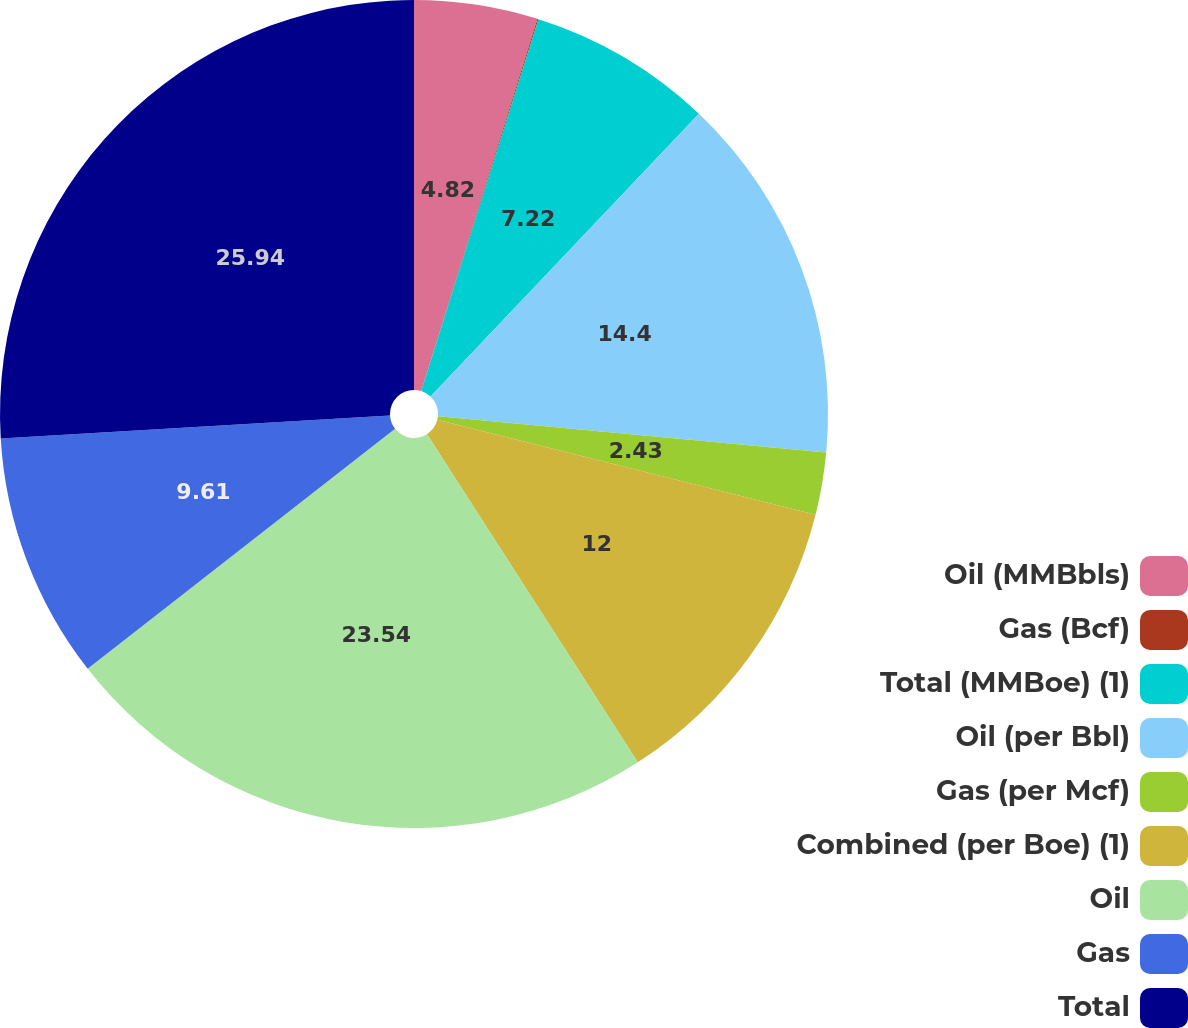Convert chart to OTSL. <chart><loc_0><loc_0><loc_500><loc_500><pie_chart><fcel>Oil (MMBbls)<fcel>Gas (Bcf)<fcel>Total (MMBoe) (1)<fcel>Oil (per Bbl)<fcel>Gas (per Mcf)<fcel>Combined (per Boe) (1)<fcel>Oil<fcel>Gas<fcel>Total<nl><fcel>4.82%<fcel>0.04%<fcel>7.22%<fcel>14.4%<fcel>2.43%<fcel>12.0%<fcel>23.54%<fcel>9.61%<fcel>25.94%<nl></chart> 